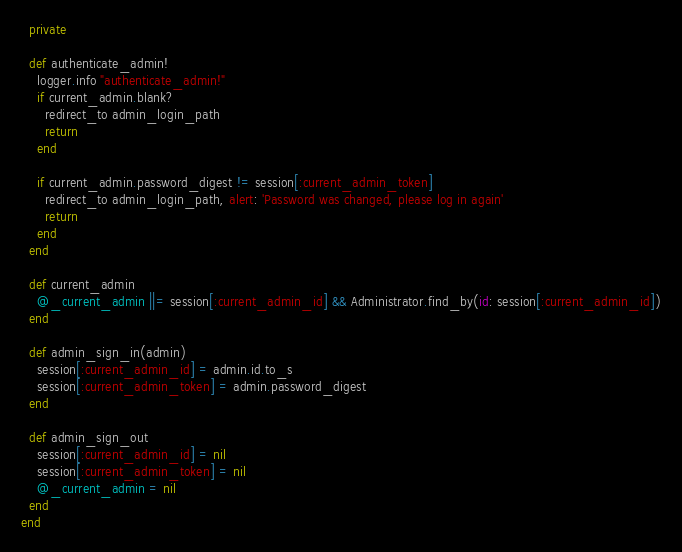Convert code to text. <code><loc_0><loc_0><loc_500><loc_500><_Ruby_>  private

  def authenticate_admin!
    logger.info "authenticate_admin!"
    if current_admin.blank?
      redirect_to admin_login_path
      return
    end

    if current_admin.password_digest != session[:current_admin_token]
      redirect_to admin_login_path, alert: 'Password was changed, please log in again'
      return
    end
  end

  def current_admin
    @_current_admin ||= session[:current_admin_id] && Administrator.find_by(id: session[:current_admin_id])
  end

  def admin_sign_in(admin)
    session[:current_admin_id] = admin.id.to_s
    session[:current_admin_token] = admin.password_digest
  end

  def admin_sign_out
    session[:current_admin_id] = nil
    session[:current_admin_token] = nil
    @_current_admin = nil
  end
end
</code> 